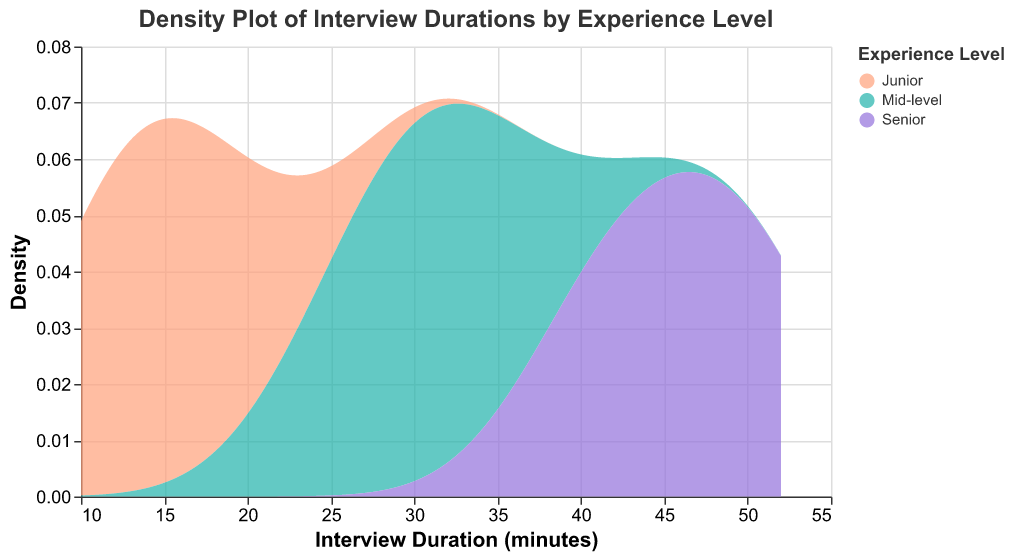What is the title of the density plot? The title of the plot is displayed at the top. It provides a quick description of the data being visualized. The title reads, "Density Plot of Interview Durations by Experience Level."
Answer: Density Plot of Interview Durations by Experience Level What are the units used on the x-axis? The x-axis units are displayed below the axis. The title of the x-axis is "Interview Duration (minutes)," indicating the units are in minutes.
Answer: minutes Which color represents the "Senior" experience level? The legend on the plot associates colors with experience levels. According to the legend, "Senior" is represented by the color purple.
Answer: purple Which experience level has the highest peak density? By examining the y-axis and the peaks of the density curves, the "Junior" group has the highest peak density because its curve reaches the highest point on the density scale.
Answer: Junior What is the approximate interview duration range for the Mid-level experience level? By examining the x-axis and the extent of the density curve for the Mid-level group, the interview duration range is approximately from 25 to 35 minutes.
Answer: 25 to 35 minutes Compare the interview durations for Junior and Senior experience levels. Which group has a wider range of durations? The range of values in the density curves provides this data. Junior has a range from about 10 to 20 minutes, while Senior has a range from about 40 to 50 minutes. The Senior group covers a wider range.
Answer: Senior What is the approximate median interview duration for the Mid-level experience level? The median is located where the density curve has equal area on both sides. For Mid-level, which ranges from 25 to 35 minutes, the median is around 30 minutes where the curve is balanced.
Answer: 30 minutes Identify the group with the highest density around 12 minutes. Looking at the curves close to 12 minutes on the x-axis, the "Junior" experience level has the highest density around that duration.
Answer: Junior Which experience level shows interview durations centered around the highest value? By inspecting the centroids of the density curves, the Senior group is centered around the highest values, from 40 to 50 minutes.
Answer: Senior 